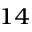<formula> <loc_0><loc_0><loc_500><loc_500>^ { 1 4 }</formula> 